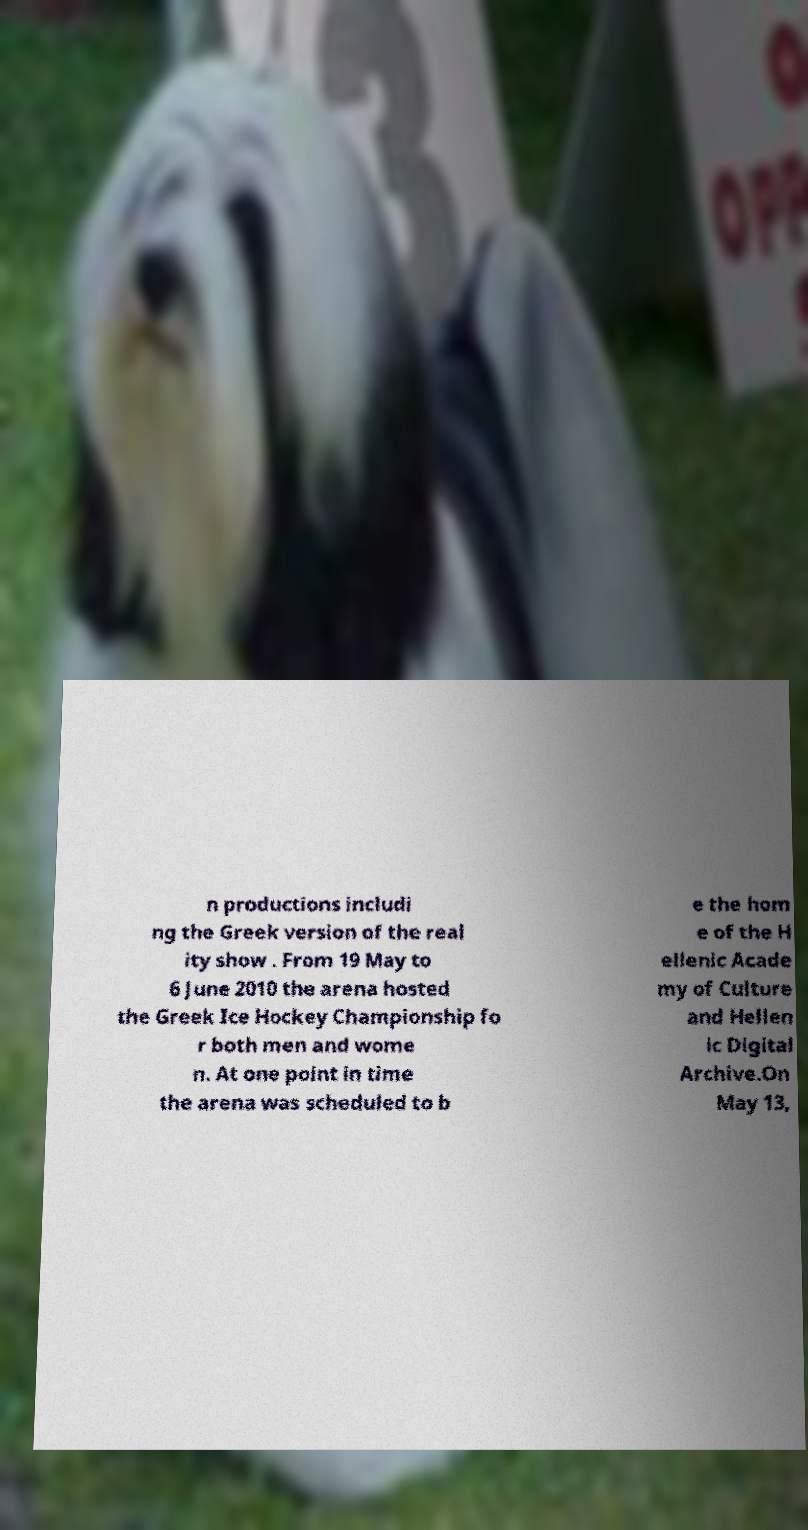Can you accurately transcribe the text from the provided image for me? n productions includi ng the Greek version of the real ity show . From 19 May to 6 June 2010 the arena hosted the Greek Ice Hockey Championship fo r both men and wome n. At one point in time the arena was scheduled to b e the hom e of the H ellenic Acade my of Culture and Hellen ic Digital Archive.On May 13, 